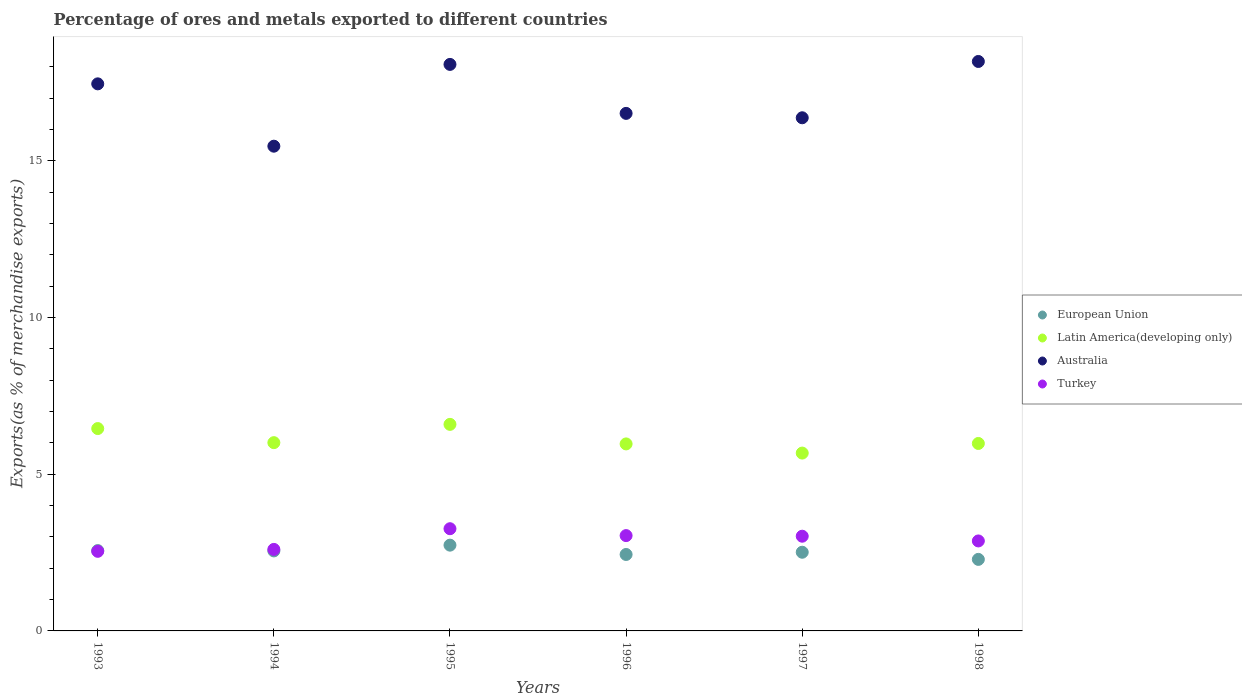How many different coloured dotlines are there?
Your answer should be compact. 4. Is the number of dotlines equal to the number of legend labels?
Provide a short and direct response. Yes. What is the percentage of exports to different countries in Australia in 1998?
Provide a short and direct response. 18.17. Across all years, what is the maximum percentage of exports to different countries in Latin America(developing only)?
Make the answer very short. 6.59. Across all years, what is the minimum percentage of exports to different countries in Turkey?
Provide a succinct answer. 2.54. In which year was the percentage of exports to different countries in Turkey maximum?
Ensure brevity in your answer.  1995. In which year was the percentage of exports to different countries in Turkey minimum?
Provide a short and direct response. 1993. What is the total percentage of exports to different countries in European Union in the graph?
Give a very brief answer. 15.09. What is the difference between the percentage of exports to different countries in European Union in 1993 and that in 1996?
Your response must be concise. 0.12. What is the difference between the percentage of exports to different countries in European Union in 1998 and the percentage of exports to different countries in Australia in 1994?
Your answer should be compact. -13.19. What is the average percentage of exports to different countries in Australia per year?
Ensure brevity in your answer.  17.01. In the year 1996, what is the difference between the percentage of exports to different countries in Australia and percentage of exports to different countries in Turkey?
Provide a succinct answer. 13.47. What is the ratio of the percentage of exports to different countries in Latin America(developing only) in 1993 to that in 1996?
Your answer should be compact. 1.08. Is the difference between the percentage of exports to different countries in Australia in 1994 and 1998 greater than the difference between the percentage of exports to different countries in Turkey in 1994 and 1998?
Keep it short and to the point. No. What is the difference between the highest and the second highest percentage of exports to different countries in Turkey?
Provide a short and direct response. 0.22. What is the difference between the highest and the lowest percentage of exports to different countries in Turkey?
Provide a short and direct response. 0.72. In how many years, is the percentage of exports to different countries in Latin America(developing only) greater than the average percentage of exports to different countries in Latin America(developing only) taken over all years?
Your answer should be very brief. 2. Is it the case that in every year, the sum of the percentage of exports to different countries in Latin America(developing only) and percentage of exports to different countries in Australia  is greater than the sum of percentage of exports to different countries in Turkey and percentage of exports to different countries in European Union?
Provide a short and direct response. Yes. Does the percentage of exports to different countries in European Union monotonically increase over the years?
Your answer should be very brief. No. How many years are there in the graph?
Provide a short and direct response. 6. Are the values on the major ticks of Y-axis written in scientific E-notation?
Ensure brevity in your answer.  No. Does the graph contain grids?
Make the answer very short. No. How many legend labels are there?
Your response must be concise. 4. How are the legend labels stacked?
Give a very brief answer. Vertical. What is the title of the graph?
Your answer should be very brief. Percentage of ores and metals exported to different countries. What is the label or title of the Y-axis?
Ensure brevity in your answer.  Exports(as % of merchandise exports). What is the Exports(as % of merchandise exports) of European Union in 1993?
Your answer should be very brief. 2.56. What is the Exports(as % of merchandise exports) in Latin America(developing only) in 1993?
Your answer should be compact. 6.46. What is the Exports(as % of merchandise exports) in Australia in 1993?
Offer a very short reply. 17.46. What is the Exports(as % of merchandise exports) in Turkey in 1993?
Offer a very short reply. 2.54. What is the Exports(as % of merchandise exports) in European Union in 1994?
Ensure brevity in your answer.  2.55. What is the Exports(as % of merchandise exports) of Latin America(developing only) in 1994?
Provide a short and direct response. 6.01. What is the Exports(as % of merchandise exports) of Australia in 1994?
Provide a succinct answer. 15.47. What is the Exports(as % of merchandise exports) in Turkey in 1994?
Give a very brief answer. 2.6. What is the Exports(as % of merchandise exports) of European Union in 1995?
Keep it short and to the point. 2.74. What is the Exports(as % of merchandise exports) in Latin America(developing only) in 1995?
Your answer should be compact. 6.59. What is the Exports(as % of merchandise exports) of Australia in 1995?
Your answer should be compact. 18.08. What is the Exports(as % of merchandise exports) of Turkey in 1995?
Ensure brevity in your answer.  3.26. What is the Exports(as % of merchandise exports) of European Union in 1996?
Keep it short and to the point. 2.44. What is the Exports(as % of merchandise exports) of Latin America(developing only) in 1996?
Provide a short and direct response. 5.97. What is the Exports(as % of merchandise exports) of Australia in 1996?
Offer a terse response. 16.52. What is the Exports(as % of merchandise exports) in Turkey in 1996?
Your answer should be compact. 3.04. What is the Exports(as % of merchandise exports) of European Union in 1997?
Offer a very short reply. 2.51. What is the Exports(as % of merchandise exports) of Latin America(developing only) in 1997?
Ensure brevity in your answer.  5.68. What is the Exports(as % of merchandise exports) in Australia in 1997?
Your response must be concise. 16.38. What is the Exports(as % of merchandise exports) of Turkey in 1997?
Provide a succinct answer. 3.02. What is the Exports(as % of merchandise exports) in European Union in 1998?
Offer a terse response. 2.28. What is the Exports(as % of merchandise exports) of Latin America(developing only) in 1998?
Provide a short and direct response. 5.98. What is the Exports(as % of merchandise exports) in Australia in 1998?
Keep it short and to the point. 18.17. What is the Exports(as % of merchandise exports) of Turkey in 1998?
Give a very brief answer. 2.87. Across all years, what is the maximum Exports(as % of merchandise exports) in European Union?
Make the answer very short. 2.74. Across all years, what is the maximum Exports(as % of merchandise exports) of Latin America(developing only)?
Keep it short and to the point. 6.59. Across all years, what is the maximum Exports(as % of merchandise exports) in Australia?
Ensure brevity in your answer.  18.17. Across all years, what is the maximum Exports(as % of merchandise exports) in Turkey?
Provide a succinct answer. 3.26. Across all years, what is the minimum Exports(as % of merchandise exports) of European Union?
Provide a succinct answer. 2.28. Across all years, what is the minimum Exports(as % of merchandise exports) of Latin America(developing only)?
Give a very brief answer. 5.68. Across all years, what is the minimum Exports(as % of merchandise exports) in Australia?
Provide a short and direct response. 15.47. Across all years, what is the minimum Exports(as % of merchandise exports) in Turkey?
Provide a short and direct response. 2.54. What is the total Exports(as % of merchandise exports) of European Union in the graph?
Provide a succinct answer. 15.09. What is the total Exports(as % of merchandise exports) of Latin America(developing only) in the graph?
Offer a very short reply. 36.68. What is the total Exports(as % of merchandise exports) of Australia in the graph?
Keep it short and to the point. 102.07. What is the total Exports(as % of merchandise exports) in Turkey in the graph?
Your answer should be compact. 17.34. What is the difference between the Exports(as % of merchandise exports) in European Union in 1993 and that in 1994?
Offer a very short reply. 0.01. What is the difference between the Exports(as % of merchandise exports) in Latin America(developing only) in 1993 and that in 1994?
Ensure brevity in your answer.  0.45. What is the difference between the Exports(as % of merchandise exports) in Australia in 1993 and that in 1994?
Your answer should be very brief. 1.99. What is the difference between the Exports(as % of merchandise exports) in Turkey in 1993 and that in 1994?
Your answer should be very brief. -0.06. What is the difference between the Exports(as % of merchandise exports) in European Union in 1993 and that in 1995?
Your answer should be very brief. -0.17. What is the difference between the Exports(as % of merchandise exports) of Latin America(developing only) in 1993 and that in 1995?
Your response must be concise. -0.13. What is the difference between the Exports(as % of merchandise exports) in Australia in 1993 and that in 1995?
Offer a very short reply. -0.62. What is the difference between the Exports(as % of merchandise exports) in Turkey in 1993 and that in 1995?
Ensure brevity in your answer.  -0.72. What is the difference between the Exports(as % of merchandise exports) in European Union in 1993 and that in 1996?
Your answer should be compact. 0.12. What is the difference between the Exports(as % of merchandise exports) in Latin America(developing only) in 1993 and that in 1996?
Provide a short and direct response. 0.49. What is the difference between the Exports(as % of merchandise exports) in Australia in 1993 and that in 1996?
Make the answer very short. 0.94. What is the difference between the Exports(as % of merchandise exports) in Turkey in 1993 and that in 1996?
Give a very brief answer. -0.5. What is the difference between the Exports(as % of merchandise exports) in European Union in 1993 and that in 1997?
Your answer should be very brief. 0.05. What is the difference between the Exports(as % of merchandise exports) of Latin America(developing only) in 1993 and that in 1997?
Your answer should be compact. 0.78. What is the difference between the Exports(as % of merchandise exports) in Australia in 1993 and that in 1997?
Ensure brevity in your answer.  1.08. What is the difference between the Exports(as % of merchandise exports) of Turkey in 1993 and that in 1997?
Your response must be concise. -0.48. What is the difference between the Exports(as % of merchandise exports) of European Union in 1993 and that in 1998?
Keep it short and to the point. 0.28. What is the difference between the Exports(as % of merchandise exports) in Latin America(developing only) in 1993 and that in 1998?
Provide a short and direct response. 0.48. What is the difference between the Exports(as % of merchandise exports) in Australia in 1993 and that in 1998?
Your answer should be compact. -0.71. What is the difference between the Exports(as % of merchandise exports) of Turkey in 1993 and that in 1998?
Your answer should be very brief. -0.33. What is the difference between the Exports(as % of merchandise exports) in European Union in 1994 and that in 1995?
Give a very brief answer. -0.18. What is the difference between the Exports(as % of merchandise exports) in Latin America(developing only) in 1994 and that in 1995?
Offer a terse response. -0.58. What is the difference between the Exports(as % of merchandise exports) of Australia in 1994 and that in 1995?
Keep it short and to the point. -2.61. What is the difference between the Exports(as % of merchandise exports) in Turkey in 1994 and that in 1995?
Ensure brevity in your answer.  -0.66. What is the difference between the Exports(as % of merchandise exports) of European Union in 1994 and that in 1996?
Provide a short and direct response. 0.11. What is the difference between the Exports(as % of merchandise exports) of Latin America(developing only) in 1994 and that in 1996?
Keep it short and to the point. 0.04. What is the difference between the Exports(as % of merchandise exports) of Australia in 1994 and that in 1996?
Provide a succinct answer. -1.05. What is the difference between the Exports(as % of merchandise exports) of Turkey in 1994 and that in 1996?
Offer a terse response. -0.44. What is the difference between the Exports(as % of merchandise exports) in European Union in 1994 and that in 1997?
Offer a very short reply. 0.04. What is the difference between the Exports(as % of merchandise exports) of Latin America(developing only) in 1994 and that in 1997?
Make the answer very short. 0.33. What is the difference between the Exports(as % of merchandise exports) of Australia in 1994 and that in 1997?
Ensure brevity in your answer.  -0.91. What is the difference between the Exports(as % of merchandise exports) in Turkey in 1994 and that in 1997?
Ensure brevity in your answer.  -0.42. What is the difference between the Exports(as % of merchandise exports) of European Union in 1994 and that in 1998?
Your response must be concise. 0.27. What is the difference between the Exports(as % of merchandise exports) of Latin America(developing only) in 1994 and that in 1998?
Provide a short and direct response. 0.03. What is the difference between the Exports(as % of merchandise exports) of Australia in 1994 and that in 1998?
Offer a very short reply. -2.7. What is the difference between the Exports(as % of merchandise exports) of Turkey in 1994 and that in 1998?
Ensure brevity in your answer.  -0.27. What is the difference between the Exports(as % of merchandise exports) of European Union in 1995 and that in 1996?
Give a very brief answer. 0.3. What is the difference between the Exports(as % of merchandise exports) in Latin America(developing only) in 1995 and that in 1996?
Your answer should be compact. 0.62. What is the difference between the Exports(as % of merchandise exports) in Australia in 1995 and that in 1996?
Offer a terse response. 1.56. What is the difference between the Exports(as % of merchandise exports) of Turkey in 1995 and that in 1996?
Give a very brief answer. 0.22. What is the difference between the Exports(as % of merchandise exports) in European Union in 1995 and that in 1997?
Ensure brevity in your answer.  0.23. What is the difference between the Exports(as % of merchandise exports) of Latin America(developing only) in 1995 and that in 1997?
Offer a very short reply. 0.92. What is the difference between the Exports(as % of merchandise exports) of Australia in 1995 and that in 1997?
Offer a terse response. 1.7. What is the difference between the Exports(as % of merchandise exports) in Turkey in 1995 and that in 1997?
Provide a succinct answer. 0.24. What is the difference between the Exports(as % of merchandise exports) in European Union in 1995 and that in 1998?
Give a very brief answer. 0.45. What is the difference between the Exports(as % of merchandise exports) of Latin America(developing only) in 1995 and that in 1998?
Make the answer very short. 0.61. What is the difference between the Exports(as % of merchandise exports) of Australia in 1995 and that in 1998?
Give a very brief answer. -0.09. What is the difference between the Exports(as % of merchandise exports) of Turkey in 1995 and that in 1998?
Make the answer very short. 0.39. What is the difference between the Exports(as % of merchandise exports) in European Union in 1996 and that in 1997?
Keep it short and to the point. -0.07. What is the difference between the Exports(as % of merchandise exports) of Latin America(developing only) in 1996 and that in 1997?
Make the answer very short. 0.29. What is the difference between the Exports(as % of merchandise exports) in Australia in 1996 and that in 1997?
Keep it short and to the point. 0.14. What is the difference between the Exports(as % of merchandise exports) in Turkey in 1996 and that in 1997?
Keep it short and to the point. 0.02. What is the difference between the Exports(as % of merchandise exports) in European Union in 1996 and that in 1998?
Your answer should be compact. 0.16. What is the difference between the Exports(as % of merchandise exports) in Latin America(developing only) in 1996 and that in 1998?
Provide a short and direct response. -0.01. What is the difference between the Exports(as % of merchandise exports) of Australia in 1996 and that in 1998?
Offer a very short reply. -1.66. What is the difference between the Exports(as % of merchandise exports) in Turkey in 1996 and that in 1998?
Your response must be concise. 0.17. What is the difference between the Exports(as % of merchandise exports) in European Union in 1997 and that in 1998?
Provide a succinct answer. 0.23. What is the difference between the Exports(as % of merchandise exports) in Latin America(developing only) in 1997 and that in 1998?
Your answer should be very brief. -0.31. What is the difference between the Exports(as % of merchandise exports) in Australia in 1997 and that in 1998?
Keep it short and to the point. -1.8. What is the difference between the Exports(as % of merchandise exports) in Turkey in 1997 and that in 1998?
Your response must be concise. 0.15. What is the difference between the Exports(as % of merchandise exports) in European Union in 1993 and the Exports(as % of merchandise exports) in Latin America(developing only) in 1994?
Your answer should be compact. -3.44. What is the difference between the Exports(as % of merchandise exports) in European Union in 1993 and the Exports(as % of merchandise exports) in Australia in 1994?
Keep it short and to the point. -12.91. What is the difference between the Exports(as % of merchandise exports) in European Union in 1993 and the Exports(as % of merchandise exports) in Turkey in 1994?
Give a very brief answer. -0.04. What is the difference between the Exports(as % of merchandise exports) of Latin America(developing only) in 1993 and the Exports(as % of merchandise exports) of Australia in 1994?
Give a very brief answer. -9.01. What is the difference between the Exports(as % of merchandise exports) of Latin America(developing only) in 1993 and the Exports(as % of merchandise exports) of Turkey in 1994?
Your answer should be very brief. 3.86. What is the difference between the Exports(as % of merchandise exports) of Australia in 1993 and the Exports(as % of merchandise exports) of Turkey in 1994?
Offer a very short reply. 14.86. What is the difference between the Exports(as % of merchandise exports) of European Union in 1993 and the Exports(as % of merchandise exports) of Latin America(developing only) in 1995?
Offer a very short reply. -4.03. What is the difference between the Exports(as % of merchandise exports) of European Union in 1993 and the Exports(as % of merchandise exports) of Australia in 1995?
Provide a short and direct response. -15.52. What is the difference between the Exports(as % of merchandise exports) of European Union in 1993 and the Exports(as % of merchandise exports) of Turkey in 1995?
Give a very brief answer. -0.7. What is the difference between the Exports(as % of merchandise exports) of Latin America(developing only) in 1993 and the Exports(as % of merchandise exports) of Australia in 1995?
Provide a succinct answer. -11.62. What is the difference between the Exports(as % of merchandise exports) in Latin America(developing only) in 1993 and the Exports(as % of merchandise exports) in Turkey in 1995?
Your response must be concise. 3.2. What is the difference between the Exports(as % of merchandise exports) of Australia in 1993 and the Exports(as % of merchandise exports) of Turkey in 1995?
Provide a short and direct response. 14.2. What is the difference between the Exports(as % of merchandise exports) of European Union in 1993 and the Exports(as % of merchandise exports) of Latin America(developing only) in 1996?
Keep it short and to the point. -3.4. What is the difference between the Exports(as % of merchandise exports) in European Union in 1993 and the Exports(as % of merchandise exports) in Australia in 1996?
Offer a terse response. -13.95. What is the difference between the Exports(as % of merchandise exports) of European Union in 1993 and the Exports(as % of merchandise exports) of Turkey in 1996?
Offer a very short reply. -0.48. What is the difference between the Exports(as % of merchandise exports) in Latin America(developing only) in 1993 and the Exports(as % of merchandise exports) in Australia in 1996?
Provide a short and direct response. -10.06. What is the difference between the Exports(as % of merchandise exports) of Latin America(developing only) in 1993 and the Exports(as % of merchandise exports) of Turkey in 1996?
Provide a succinct answer. 3.42. What is the difference between the Exports(as % of merchandise exports) of Australia in 1993 and the Exports(as % of merchandise exports) of Turkey in 1996?
Ensure brevity in your answer.  14.42. What is the difference between the Exports(as % of merchandise exports) of European Union in 1993 and the Exports(as % of merchandise exports) of Latin America(developing only) in 1997?
Ensure brevity in your answer.  -3.11. What is the difference between the Exports(as % of merchandise exports) of European Union in 1993 and the Exports(as % of merchandise exports) of Australia in 1997?
Make the answer very short. -13.81. What is the difference between the Exports(as % of merchandise exports) in European Union in 1993 and the Exports(as % of merchandise exports) in Turkey in 1997?
Your answer should be very brief. -0.46. What is the difference between the Exports(as % of merchandise exports) of Latin America(developing only) in 1993 and the Exports(as % of merchandise exports) of Australia in 1997?
Keep it short and to the point. -9.92. What is the difference between the Exports(as % of merchandise exports) of Latin America(developing only) in 1993 and the Exports(as % of merchandise exports) of Turkey in 1997?
Keep it short and to the point. 3.44. What is the difference between the Exports(as % of merchandise exports) of Australia in 1993 and the Exports(as % of merchandise exports) of Turkey in 1997?
Provide a short and direct response. 14.44. What is the difference between the Exports(as % of merchandise exports) of European Union in 1993 and the Exports(as % of merchandise exports) of Latin America(developing only) in 1998?
Your answer should be very brief. -3.42. What is the difference between the Exports(as % of merchandise exports) in European Union in 1993 and the Exports(as % of merchandise exports) in Australia in 1998?
Make the answer very short. -15.61. What is the difference between the Exports(as % of merchandise exports) in European Union in 1993 and the Exports(as % of merchandise exports) in Turkey in 1998?
Make the answer very short. -0.31. What is the difference between the Exports(as % of merchandise exports) of Latin America(developing only) in 1993 and the Exports(as % of merchandise exports) of Australia in 1998?
Make the answer very short. -11.72. What is the difference between the Exports(as % of merchandise exports) in Latin America(developing only) in 1993 and the Exports(as % of merchandise exports) in Turkey in 1998?
Give a very brief answer. 3.59. What is the difference between the Exports(as % of merchandise exports) in Australia in 1993 and the Exports(as % of merchandise exports) in Turkey in 1998?
Your answer should be very brief. 14.59. What is the difference between the Exports(as % of merchandise exports) of European Union in 1994 and the Exports(as % of merchandise exports) of Latin America(developing only) in 1995?
Offer a very short reply. -4.04. What is the difference between the Exports(as % of merchandise exports) in European Union in 1994 and the Exports(as % of merchandise exports) in Australia in 1995?
Keep it short and to the point. -15.53. What is the difference between the Exports(as % of merchandise exports) of European Union in 1994 and the Exports(as % of merchandise exports) of Turkey in 1995?
Ensure brevity in your answer.  -0.71. What is the difference between the Exports(as % of merchandise exports) in Latin America(developing only) in 1994 and the Exports(as % of merchandise exports) in Australia in 1995?
Give a very brief answer. -12.07. What is the difference between the Exports(as % of merchandise exports) in Latin America(developing only) in 1994 and the Exports(as % of merchandise exports) in Turkey in 1995?
Keep it short and to the point. 2.75. What is the difference between the Exports(as % of merchandise exports) in Australia in 1994 and the Exports(as % of merchandise exports) in Turkey in 1995?
Your answer should be compact. 12.21. What is the difference between the Exports(as % of merchandise exports) of European Union in 1994 and the Exports(as % of merchandise exports) of Latin America(developing only) in 1996?
Provide a succinct answer. -3.42. What is the difference between the Exports(as % of merchandise exports) in European Union in 1994 and the Exports(as % of merchandise exports) in Australia in 1996?
Offer a very short reply. -13.96. What is the difference between the Exports(as % of merchandise exports) of European Union in 1994 and the Exports(as % of merchandise exports) of Turkey in 1996?
Provide a short and direct response. -0.49. What is the difference between the Exports(as % of merchandise exports) of Latin America(developing only) in 1994 and the Exports(as % of merchandise exports) of Australia in 1996?
Provide a succinct answer. -10.51. What is the difference between the Exports(as % of merchandise exports) in Latin America(developing only) in 1994 and the Exports(as % of merchandise exports) in Turkey in 1996?
Provide a short and direct response. 2.97. What is the difference between the Exports(as % of merchandise exports) of Australia in 1994 and the Exports(as % of merchandise exports) of Turkey in 1996?
Your response must be concise. 12.43. What is the difference between the Exports(as % of merchandise exports) in European Union in 1994 and the Exports(as % of merchandise exports) in Latin America(developing only) in 1997?
Your answer should be compact. -3.12. What is the difference between the Exports(as % of merchandise exports) in European Union in 1994 and the Exports(as % of merchandise exports) in Australia in 1997?
Make the answer very short. -13.82. What is the difference between the Exports(as % of merchandise exports) in European Union in 1994 and the Exports(as % of merchandise exports) in Turkey in 1997?
Keep it short and to the point. -0.47. What is the difference between the Exports(as % of merchandise exports) in Latin America(developing only) in 1994 and the Exports(as % of merchandise exports) in Australia in 1997?
Offer a terse response. -10.37. What is the difference between the Exports(as % of merchandise exports) in Latin America(developing only) in 1994 and the Exports(as % of merchandise exports) in Turkey in 1997?
Provide a short and direct response. 2.99. What is the difference between the Exports(as % of merchandise exports) of Australia in 1994 and the Exports(as % of merchandise exports) of Turkey in 1997?
Offer a very short reply. 12.45. What is the difference between the Exports(as % of merchandise exports) in European Union in 1994 and the Exports(as % of merchandise exports) in Latin America(developing only) in 1998?
Your answer should be compact. -3.43. What is the difference between the Exports(as % of merchandise exports) of European Union in 1994 and the Exports(as % of merchandise exports) of Australia in 1998?
Your answer should be very brief. -15.62. What is the difference between the Exports(as % of merchandise exports) of European Union in 1994 and the Exports(as % of merchandise exports) of Turkey in 1998?
Your answer should be compact. -0.32. What is the difference between the Exports(as % of merchandise exports) of Latin America(developing only) in 1994 and the Exports(as % of merchandise exports) of Australia in 1998?
Offer a terse response. -12.16. What is the difference between the Exports(as % of merchandise exports) in Latin America(developing only) in 1994 and the Exports(as % of merchandise exports) in Turkey in 1998?
Offer a terse response. 3.14. What is the difference between the Exports(as % of merchandise exports) of Australia in 1994 and the Exports(as % of merchandise exports) of Turkey in 1998?
Offer a terse response. 12.6. What is the difference between the Exports(as % of merchandise exports) of European Union in 1995 and the Exports(as % of merchandise exports) of Latin America(developing only) in 1996?
Your response must be concise. -3.23. What is the difference between the Exports(as % of merchandise exports) of European Union in 1995 and the Exports(as % of merchandise exports) of Australia in 1996?
Provide a succinct answer. -13.78. What is the difference between the Exports(as % of merchandise exports) of European Union in 1995 and the Exports(as % of merchandise exports) of Turkey in 1996?
Provide a succinct answer. -0.3. What is the difference between the Exports(as % of merchandise exports) in Latin America(developing only) in 1995 and the Exports(as % of merchandise exports) in Australia in 1996?
Give a very brief answer. -9.92. What is the difference between the Exports(as % of merchandise exports) in Latin America(developing only) in 1995 and the Exports(as % of merchandise exports) in Turkey in 1996?
Offer a very short reply. 3.55. What is the difference between the Exports(as % of merchandise exports) in Australia in 1995 and the Exports(as % of merchandise exports) in Turkey in 1996?
Your answer should be very brief. 15.04. What is the difference between the Exports(as % of merchandise exports) of European Union in 1995 and the Exports(as % of merchandise exports) of Latin America(developing only) in 1997?
Offer a very short reply. -2.94. What is the difference between the Exports(as % of merchandise exports) in European Union in 1995 and the Exports(as % of merchandise exports) in Australia in 1997?
Your answer should be very brief. -13.64. What is the difference between the Exports(as % of merchandise exports) of European Union in 1995 and the Exports(as % of merchandise exports) of Turkey in 1997?
Your response must be concise. -0.29. What is the difference between the Exports(as % of merchandise exports) of Latin America(developing only) in 1995 and the Exports(as % of merchandise exports) of Australia in 1997?
Give a very brief answer. -9.78. What is the difference between the Exports(as % of merchandise exports) in Latin America(developing only) in 1995 and the Exports(as % of merchandise exports) in Turkey in 1997?
Offer a very short reply. 3.57. What is the difference between the Exports(as % of merchandise exports) in Australia in 1995 and the Exports(as % of merchandise exports) in Turkey in 1997?
Offer a terse response. 15.06. What is the difference between the Exports(as % of merchandise exports) of European Union in 1995 and the Exports(as % of merchandise exports) of Latin America(developing only) in 1998?
Offer a very short reply. -3.25. What is the difference between the Exports(as % of merchandise exports) of European Union in 1995 and the Exports(as % of merchandise exports) of Australia in 1998?
Your response must be concise. -15.44. What is the difference between the Exports(as % of merchandise exports) of European Union in 1995 and the Exports(as % of merchandise exports) of Turkey in 1998?
Make the answer very short. -0.13. What is the difference between the Exports(as % of merchandise exports) in Latin America(developing only) in 1995 and the Exports(as % of merchandise exports) in Australia in 1998?
Provide a succinct answer. -11.58. What is the difference between the Exports(as % of merchandise exports) in Latin America(developing only) in 1995 and the Exports(as % of merchandise exports) in Turkey in 1998?
Make the answer very short. 3.72. What is the difference between the Exports(as % of merchandise exports) in Australia in 1995 and the Exports(as % of merchandise exports) in Turkey in 1998?
Offer a terse response. 15.21. What is the difference between the Exports(as % of merchandise exports) of European Union in 1996 and the Exports(as % of merchandise exports) of Latin America(developing only) in 1997?
Provide a succinct answer. -3.24. What is the difference between the Exports(as % of merchandise exports) of European Union in 1996 and the Exports(as % of merchandise exports) of Australia in 1997?
Offer a terse response. -13.94. What is the difference between the Exports(as % of merchandise exports) in European Union in 1996 and the Exports(as % of merchandise exports) in Turkey in 1997?
Your response must be concise. -0.58. What is the difference between the Exports(as % of merchandise exports) of Latin America(developing only) in 1996 and the Exports(as % of merchandise exports) of Australia in 1997?
Your response must be concise. -10.41. What is the difference between the Exports(as % of merchandise exports) of Latin America(developing only) in 1996 and the Exports(as % of merchandise exports) of Turkey in 1997?
Your answer should be compact. 2.95. What is the difference between the Exports(as % of merchandise exports) in Australia in 1996 and the Exports(as % of merchandise exports) in Turkey in 1997?
Give a very brief answer. 13.49. What is the difference between the Exports(as % of merchandise exports) of European Union in 1996 and the Exports(as % of merchandise exports) of Latin America(developing only) in 1998?
Offer a very short reply. -3.54. What is the difference between the Exports(as % of merchandise exports) in European Union in 1996 and the Exports(as % of merchandise exports) in Australia in 1998?
Provide a short and direct response. -15.73. What is the difference between the Exports(as % of merchandise exports) in European Union in 1996 and the Exports(as % of merchandise exports) in Turkey in 1998?
Your response must be concise. -0.43. What is the difference between the Exports(as % of merchandise exports) of Latin America(developing only) in 1996 and the Exports(as % of merchandise exports) of Australia in 1998?
Keep it short and to the point. -12.21. What is the difference between the Exports(as % of merchandise exports) in Latin America(developing only) in 1996 and the Exports(as % of merchandise exports) in Turkey in 1998?
Keep it short and to the point. 3.1. What is the difference between the Exports(as % of merchandise exports) of Australia in 1996 and the Exports(as % of merchandise exports) of Turkey in 1998?
Provide a succinct answer. 13.64. What is the difference between the Exports(as % of merchandise exports) in European Union in 1997 and the Exports(as % of merchandise exports) in Latin America(developing only) in 1998?
Your response must be concise. -3.47. What is the difference between the Exports(as % of merchandise exports) of European Union in 1997 and the Exports(as % of merchandise exports) of Australia in 1998?
Your response must be concise. -15.66. What is the difference between the Exports(as % of merchandise exports) of European Union in 1997 and the Exports(as % of merchandise exports) of Turkey in 1998?
Ensure brevity in your answer.  -0.36. What is the difference between the Exports(as % of merchandise exports) of Latin America(developing only) in 1997 and the Exports(as % of merchandise exports) of Australia in 1998?
Offer a very short reply. -12.5. What is the difference between the Exports(as % of merchandise exports) in Latin America(developing only) in 1997 and the Exports(as % of merchandise exports) in Turkey in 1998?
Make the answer very short. 2.8. What is the difference between the Exports(as % of merchandise exports) of Australia in 1997 and the Exports(as % of merchandise exports) of Turkey in 1998?
Your answer should be compact. 13.5. What is the average Exports(as % of merchandise exports) in European Union per year?
Your answer should be compact. 2.51. What is the average Exports(as % of merchandise exports) of Latin America(developing only) per year?
Ensure brevity in your answer.  6.11. What is the average Exports(as % of merchandise exports) of Australia per year?
Ensure brevity in your answer.  17.01. What is the average Exports(as % of merchandise exports) in Turkey per year?
Provide a short and direct response. 2.89. In the year 1993, what is the difference between the Exports(as % of merchandise exports) of European Union and Exports(as % of merchandise exports) of Latin America(developing only)?
Ensure brevity in your answer.  -3.89. In the year 1993, what is the difference between the Exports(as % of merchandise exports) of European Union and Exports(as % of merchandise exports) of Australia?
Provide a succinct answer. -14.89. In the year 1993, what is the difference between the Exports(as % of merchandise exports) in European Union and Exports(as % of merchandise exports) in Turkey?
Keep it short and to the point. 0.02. In the year 1993, what is the difference between the Exports(as % of merchandise exports) of Latin America(developing only) and Exports(as % of merchandise exports) of Australia?
Offer a very short reply. -11. In the year 1993, what is the difference between the Exports(as % of merchandise exports) in Latin America(developing only) and Exports(as % of merchandise exports) in Turkey?
Give a very brief answer. 3.92. In the year 1993, what is the difference between the Exports(as % of merchandise exports) of Australia and Exports(as % of merchandise exports) of Turkey?
Keep it short and to the point. 14.92. In the year 1994, what is the difference between the Exports(as % of merchandise exports) of European Union and Exports(as % of merchandise exports) of Latin America(developing only)?
Your answer should be compact. -3.46. In the year 1994, what is the difference between the Exports(as % of merchandise exports) in European Union and Exports(as % of merchandise exports) in Australia?
Ensure brevity in your answer.  -12.92. In the year 1994, what is the difference between the Exports(as % of merchandise exports) in European Union and Exports(as % of merchandise exports) in Turkey?
Provide a short and direct response. -0.05. In the year 1994, what is the difference between the Exports(as % of merchandise exports) in Latin America(developing only) and Exports(as % of merchandise exports) in Australia?
Keep it short and to the point. -9.46. In the year 1994, what is the difference between the Exports(as % of merchandise exports) of Latin America(developing only) and Exports(as % of merchandise exports) of Turkey?
Ensure brevity in your answer.  3.41. In the year 1994, what is the difference between the Exports(as % of merchandise exports) in Australia and Exports(as % of merchandise exports) in Turkey?
Ensure brevity in your answer.  12.87. In the year 1995, what is the difference between the Exports(as % of merchandise exports) in European Union and Exports(as % of merchandise exports) in Latin America(developing only)?
Provide a short and direct response. -3.85. In the year 1995, what is the difference between the Exports(as % of merchandise exports) in European Union and Exports(as % of merchandise exports) in Australia?
Your answer should be compact. -15.34. In the year 1995, what is the difference between the Exports(as % of merchandise exports) of European Union and Exports(as % of merchandise exports) of Turkey?
Your answer should be very brief. -0.52. In the year 1995, what is the difference between the Exports(as % of merchandise exports) in Latin America(developing only) and Exports(as % of merchandise exports) in Australia?
Offer a very short reply. -11.49. In the year 1995, what is the difference between the Exports(as % of merchandise exports) of Latin America(developing only) and Exports(as % of merchandise exports) of Turkey?
Your answer should be compact. 3.33. In the year 1995, what is the difference between the Exports(as % of merchandise exports) in Australia and Exports(as % of merchandise exports) in Turkey?
Provide a succinct answer. 14.82. In the year 1996, what is the difference between the Exports(as % of merchandise exports) in European Union and Exports(as % of merchandise exports) in Latin America(developing only)?
Offer a very short reply. -3.53. In the year 1996, what is the difference between the Exports(as % of merchandise exports) of European Union and Exports(as % of merchandise exports) of Australia?
Make the answer very short. -14.08. In the year 1996, what is the difference between the Exports(as % of merchandise exports) in European Union and Exports(as % of merchandise exports) in Turkey?
Give a very brief answer. -0.6. In the year 1996, what is the difference between the Exports(as % of merchandise exports) in Latin America(developing only) and Exports(as % of merchandise exports) in Australia?
Provide a short and direct response. -10.55. In the year 1996, what is the difference between the Exports(as % of merchandise exports) in Latin America(developing only) and Exports(as % of merchandise exports) in Turkey?
Make the answer very short. 2.93. In the year 1996, what is the difference between the Exports(as % of merchandise exports) in Australia and Exports(as % of merchandise exports) in Turkey?
Offer a very short reply. 13.47. In the year 1997, what is the difference between the Exports(as % of merchandise exports) of European Union and Exports(as % of merchandise exports) of Latin America(developing only)?
Your answer should be very brief. -3.16. In the year 1997, what is the difference between the Exports(as % of merchandise exports) of European Union and Exports(as % of merchandise exports) of Australia?
Your answer should be very brief. -13.87. In the year 1997, what is the difference between the Exports(as % of merchandise exports) in European Union and Exports(as % of merchandise exports) in Turkey?
Give a very brief answer. -0.51. In the year 1997, what is the difference between the Exports(as % of merchandise exports) of Latin America(developing only) and Exports(as % of merchandise exports) of Australia?
Keep it short and to the point. -10.7. In the year 1997, what is the difference between the Exports(as % of merchandise exports) in Latin America(developing only) and Exports(as % of merchandise exports) in Turkey?
Your answer should be very brief. 2.65. In the year 1997, what is the difference between the Exports(as % of merchandise exports) of Australia and Exports(as % of merchandise exports) of Turkey?
Ensure brevity in your answer.  13.35. In the year 1998, what is the difference between the Exports(as % of merchandise exports) of European Union and Exports(as % of merchandise exports) of Latin America(developing only)?
Make the answer very short. -3.7. In the year 1998, what is the difference between the Exports(as % of merchandise exports) of European Union and Exports(as % of merchandise exports) of Australia?
Ensure brevity in your answer.  -15.89. In the year 1998, what is the difference between the Exports(as % of merchandise exports) of European Union and Exports(as % of merchandise exports) of Turkey?
Your response must be concise. -0.59. In the year 1998, what is the difference between the Exports(as % of merchandise exports) in Latin America(developing only) and Exports(as % of merchandise exports) in Australia?
Provide a short and direct response. -12.19. In the year 1998, what is the difference between the Exports(as % of merchandise exports) of Latin America(developing only) and Exports(as % of merchandise exports) of Turkey?
Provide a short and direct response. 3.11. In the year 1998, what is the difference between the Exports(as % of merchandise exports) in Australia and Exports(as % of merchandise exports) in Turkey?
Give a very brief answer. 15.3. What is the ratio of the Exports(as % of merchandise exports) of Latin America(developing only) in 1993 to that in 1994?
Ensure brevity in your answer.  1.07. What is the ratio of the Exports(as % of merchandise exports) of Australia in 1993 to that in 1994?
Give a very brief answer. 1.13. What is the ratio of the Exports(as % of merchandise exports) of Turkey in 1993 to that in 1994?
Your answer should be very brief. 0.98. What is the ratio of the Exports(as % of merchandise exports) of European Union in 1993 to that in 1995?
Provide a short and direct response. 0.94. What is the ratio of the Exports(as % of merchandise exports) in Latin America(developing only) in 1993 to that in 1995?
Your answer should be very brief. 0.98. What is the ratio of the Exports(as % of merchandise exports) of Australia in 1993 to that in 1995?
Your response must be concise. 0.97. What is the ratio of the Exports(as % of merchandise exports) in Turkey in 1993 to that in 1995?
Offer a terse response. 0.78. What is the ratio of the Exports(as % of merchandise exports) of European Union in 1993 to that in 1996?
Keep it short and to the point. 1.05. What is the ratio of the Exports(as % of merchandise exports) in Latin America(developing only) in 1993 to that in 1996?
Your response must be concise. 1.08. What is the ratio of the Exports(as % of merchandise exports) of Australia in 1993 to that in 1996?
Offer a very short reply. 1.06. What is the ratio of the Exports(as % of merchandise exports) in Turkey in 1993 to that in 1996?
Offer a very short reply. 0.84. What is the ratio of the Exports(as % of merchandise exports) in European Union in 1993 to that in 1997?
Your answer should be very brief. 1.02. What is the ratio of the Exports(as % of merchandise exports) in Latin America(developing only) in 1993 to that in 1997?
Keep it short and to the point. 1.14. What is the ratio of the Exports(as % of merchandise exports) in Australia in 1993 to that in 1997?
Your answer should be compact. 1.07. What is the ratio of the Exports(as % of merchandise exports) of Turkey in 1993 to that in 1997?
Your answer should be compact. 0.84. What is the ratio of the Exports(as % of merchandise exports) of European Union in 1993 to that in 1998?
Your answer should be very brief. 1.12. What is the ratio of the Exports(as % of merchandise exports) of Latin America(developing only) in 1993 to that in 1998?
Make the answer very short. 1.08. What is the ratio of the Exports(as % of merchandise exports) of Australia in 1993 to that in 1998?
Offer a terse response. 0.96. What is the ratio of the Exports(as % of merchandise exports) of Turkey in 1993 to that in 1998?
Give a very brief answer. 0.88. What is the ratio of the Exports(as % of merchandise exports) of European Union in 1994 to that in 1995?
Provide a succinct answer. 0.93. What is the ratio of the Exports(as % of merchandise exports) of Latin America(developing only) in 1994 to that in 1995?
Ensure brevity in your answer.  0.91. What is the ratio of the Exports(as % of merchandise exports) of Australia in 1994 to that in 1995?
Your response must be concise. 0.86. What is the ratio of the Exports(as % of merchandise exports) in Turkey in 1994 to that in 1995?
Offer a very short reply. 0.8. What is the ratio of the Exports(as % of merchandise exports) in European Union in 1994 to that in 1996?
Your answer should be compact. 1.05. What is the ratio of the Exports(as % of merchandise exports) in Latin America(developing only) in 1994 to that in 1996?
Keep it short and to the point. 1.01. What is the ratio of the Exports(as % of merchandise exports) in Australia in 1994 to that in 1996?
Your response must be concise. 0.94. What is the ratio of the Exports(as % of merchandise exports) in Turkey in 1994 to that in 1996?
Provide a short and direct response. 0.86. What is the ratio of the Exports(as % of merchandise exports) of European Union in 1994 to that in 1997?
Provide a succinct answer. 1.02. What is the ratio of the Exports(as % of merchandise exports) of Latin America(developing only) in 1994 to that in 1997?
Provide a succinct answer. 1.06. What is the ratio of the Exports(as % of merchandise exports) in Australia in 1994 to that in 1997?
Offer a very short reply. 0.94. What is the ratio of the Exports(as % of merchandise exports) in Turkey in 1994 to that in 1997?
Your answer should be very brief. 0.86. What is the ratio of the Exports(as % of merchandise exports) of European Union in 1994 to that in 1998?
Your answer should be compact. 1.12. What is the ratio of the Exports(as % of merchandise exports) in Latin America(developing only) in 1994 to that in 1998?
Your answer should be compact. 1. What is the ratio of the Exports(as % of merchandise exports) in Australia in 1994 to that in 1998?
Offer a terse response. 0.85. What is the ratio of the Exports(as % of merchandise exports) in Turkey in 1994 to that in 1998?
Make the answer very short. 0.91. What is the ratio of the Exports(as % of merchandise exports) of European Union in 1995 to that in 1996?
Provide a short and direct response. 1.12. What is the ratio of the Exports(as % of merchandise exports) in Latin America(developing only) in 1995 to that in 1996?
Your answer should be very brief. 1.1. What is the ratio of the Exports(as % of merchandise exports) in Australia in 1995 to that in 1996?
Provide a succinct answer. 1.09. What is the ratio of the Exports(as % of merchandise exports) of Turkey in 1995 to that in 1996?
Your response must be concise. 1.07. What is the ratio of the Exports(as % of merchandise exports) of European Union in 1995 to that in 1997?
Your answer should be compact. 1.09. What is the ratio of the Exports(as % of merchandise exports) of Latin America(developing only) in 1995 to that in 1997?
Offer a very short reply. 1.16. What is the ratio of the Exports(as % of merchandise exports) in Australia in 1995 to that in 1997?
Make the answer very short. 1.1. What is the ratio of the Exports(as % of merchandise exports) in Turkey in 1995 to that in 1997?
Your response must be concise. 1.08. What is the ratio of the Exports(as % of merchandise exports) in European Union in 1995 to that in 1998?
Provide a succinct answer. 1.2. What is the ratio of the Exports(as % of merchandise exports) in Latin America(developing only) in 1995 to that in 1998?
Make the answer very short. 1.1. What is the ratio of the Exports(as % of merchandise exports) of Australia in 1995 to that in 1998?
Your response must be concise. 0.99. What is the ratio of the Exports(as % of merchandise exports) of Turkey in 1995 to that in 1998?
Your answer should be very brief. 1.14. What is the ratio of the Exports(as % of merchandise exports) of European Union in 1996 to that in 1997?
Your response must be concise. 0.97. What is the ratio of the Exports(as % of merchandise exports) in Latin America(developing only) in 1996 to that in 1997?
Ensure brevity in your answer.  1.05. What is the ratio of the Exports(as % of merchandise exports) of Australia in 1996 to that in 1997?
Ensure brevity in your answer.  1.01. What is the ratio of the Exports(as % of merchandise exports) in European Union in 1996 to that in 1998?
Your answer should be compact. 1.07. What is the ratio of the Exports(as % of merchandise exports) in Australia in 1996 to that in 1998?
Make the answer very short. 0.91. What is the ratio of the Exports(as % of merchandise exports) in Turkey in 1996 to that in 1998?
Ensure brevity in your answer.  1.06. What is the ratio of the Exports(as % of merchandise exports) of European Union in 1997 to that in 1998?
Keep it short and to the point. 1.1. What is the ratio of the Exports(as % of merchandise exports) in Latin America(developing only) in 1997 to that in 1998?
Provide a short and direct response. 0.95. What is the ratio of the Exports(as % of merchandise exports) of Australia in 1997 to that in 1998?
Provide a short and direct response. 0.9. What is the ratio of the Exports(as % of merchandise exports) of Turkey in 1997 to that in 1998?
Offer a terse response. 1.05. What is the difference between the highest and the second highest Exports(as % of merchandise exports) of European Union?
Keep it short and to the point. 0.17. What is the difference between the highest and the second highest Exports(as % of merchandise exports) of Latin America(developing only)?
Your answer should be compact. 0.13. What is the difference between the highest and the second highest Exports(as % of merchandise exports) of Australia?
Your answer should be compact. 0.09. What is the difference between the highest and the second highest Exports(as % of merchandise exports) of Turkey?
Make the answer very short. 0.22. What is the difference between the highest and the lowest Exports(as % of merchandise exports) of European Union?
Provide a succinct answer. 0.45. What is the difference between the highest and the lowest Exports(as % of merchandise exports) of Latin America(developing only)?
Your answer should be very brief. 0.92. What is the difference between the highest and the lowest Exports(as % of merchandise exports) of Australia?
Your answer should be compact. 2.7. What is the difference between the highest and the lowest Exports(as % of merchandise exports) in Turkey?
Keep it short and to the point. 0.72. 